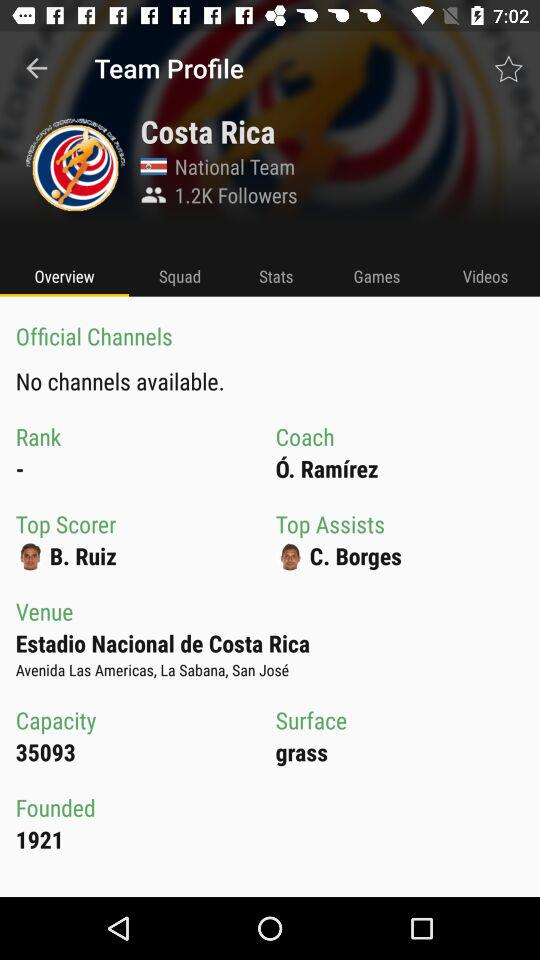What is the venue? The venue is Estadio Nacional de Costa Rica. 